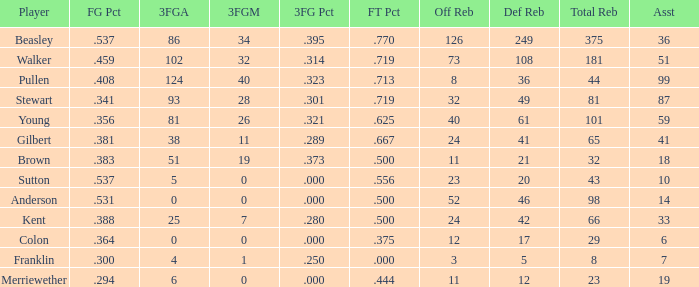Can you give me this table as a dict? {'header': ['Player', 'FG Pct', '3FGA', '3FGM', '3FG Pct', 'FT Pct', 'Off Reb', 'Def Reb', 'Total Reb', 'Asst'], 'rows': [['Beasley', '.537', '86', '34', '.395', '.770', '126', '249', '375', '36'], ['Walker', '.459', '102', '32', '.314', '.719', '73', '108', '181', '51'], ['Pullen', '.408', '124', '40', '.323', '.713', '8', '36', '44', '99'], ['Stewart', '.341', '93', '28', '.301', '.719', '32', '49', '81', '87'], ['Young', '.356', '81', '26', '.321', '.625', '40', '61', '101', '59'], ['Gilbert', '.381', '38', '11', '.289', '.667', '24', '41', '65', '41'], ['Brown', '.383', '51', '19', '.373', '.500', '11', '21', '32', '18'], ['Sutton', '.537', '5', '0', '.000', '.556', '23', '20', '43', '10'], ['Anderson', '.531', '0', '0', '.000', '.500', '52', '46', '98', '14'], ['Kent', '.388', '25', '7', '.280', '.500', '24', '42', '66', '33'], ['Colon', '.364', '0', '0', '.000', '.375', '12', '17', '29', '6'], ['Franklin', '.300', '4', '1', '.250', '.000', '3', '5', '8', '7'], ['Merriewether', '.294', '6', '0', '.000', '.444', '11', '12', '23', '19']]} What is the complete sum of offensive rebounds for individuals with less than 65 total rebounds, 5 defensive rebounds, and fewer than 7 assists? 0.0. 